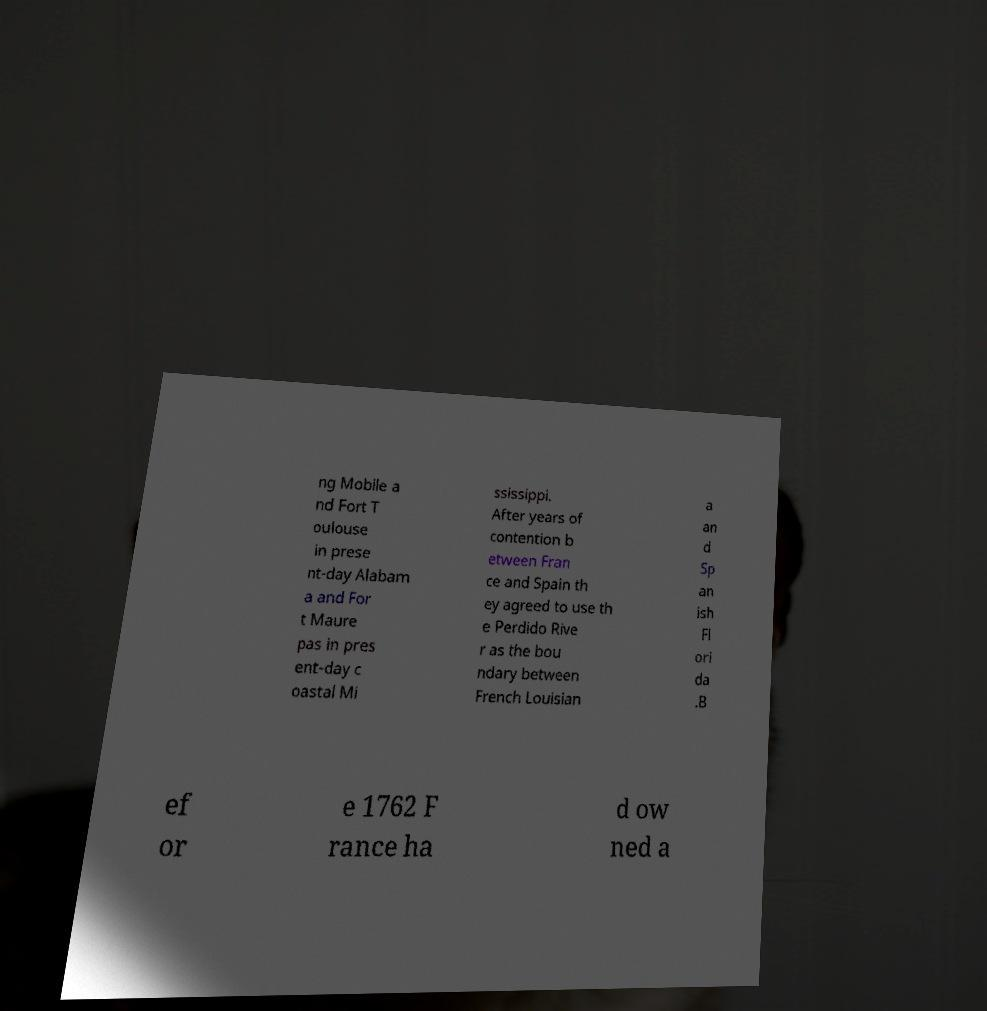Can you accurately transcribe the text from the provided image for me? ng Mobile a nd Fort T oulouse in prese nt-day Alabam a and For t Maure pas in pres ent-day c oastal Mi ssissippi. After years of contention b etween Fran ce and Spain th ey agreed to use th e Perdido Rive r as the bou ndary between French Louisian a an d Sp an ish Fl ori da .B ef or e 1762 F rance ha d ow ned a 